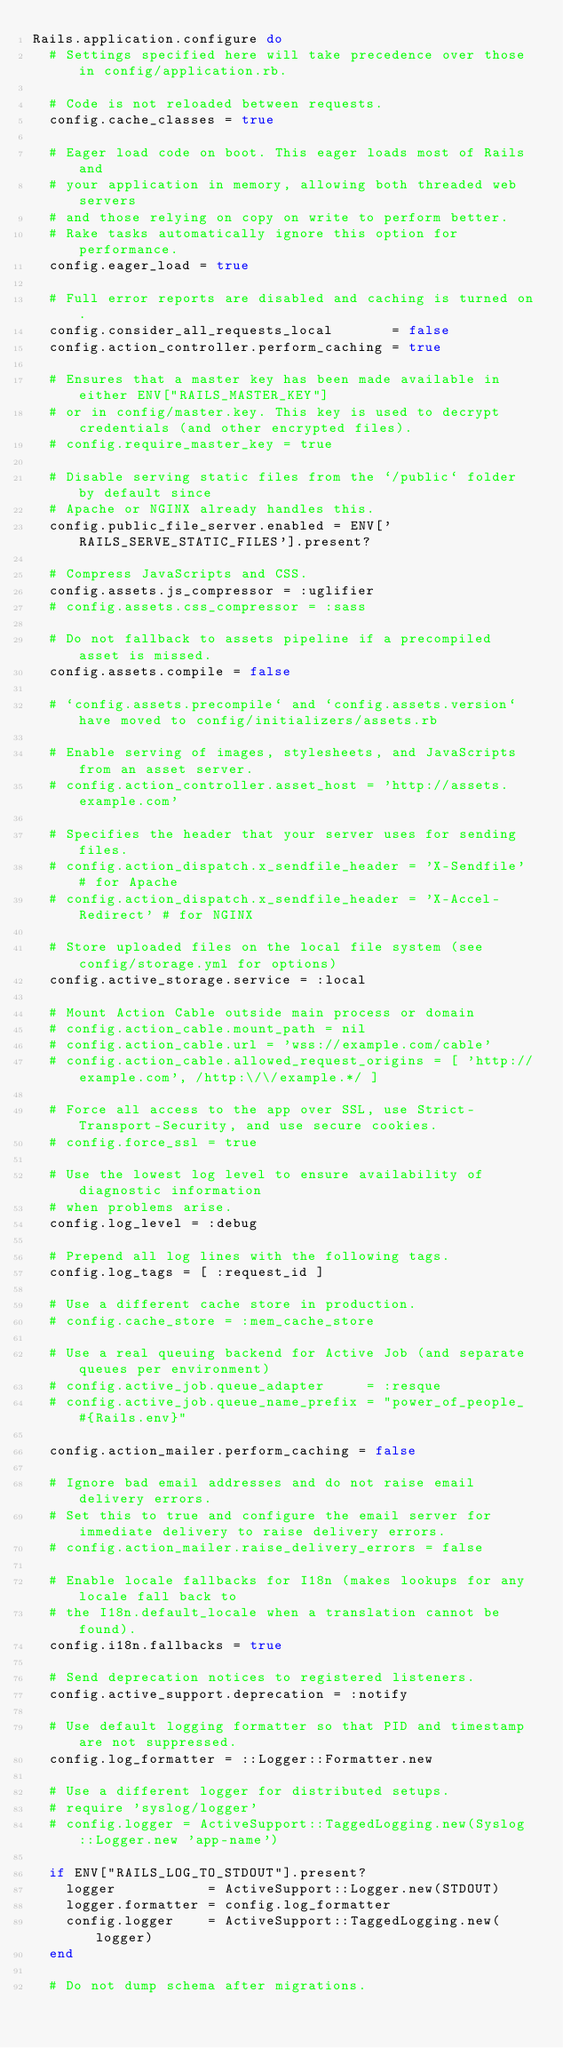<code> <loc_0><loc_0><loc_500><loc_500><_Ruby_>Rails.application.configure do
  # Settings specified here will take precedence over those in config/application.rb.

  # Code is not reloaded between requests.
  config.cache_classes = true

  # Eager load code on boot. This eager loads most of Rails and
  # your application in memory, allowing both threaded web servers
  # and those relying on copy on write to perform better.
  # Rake tasks automatically ignore this option for performance.
  config.eager_load = true

  # Full error reports are disabled and caching is turned on.
  config.consider_all_requests_local       = false
  config.action_controller.perform_caching = true

  # Ensures that a master key has been made available in either ENV["RAILS_MASTER_KEY"]
  # or in config/master.key. This key is used to decrypt credentials (and other encrypted files).
  # config.require_master_key = true

  # Disable serving static files from the `/public` folder by default since
  # Apache or NGINX already handles this.
  config.public_file_server.enabled = ENV['RAILS_SERVE_STATIC_FILES'].present?

  # Compress JavaScripts and CSS.
  config.assets.js_compressor = :uglifier
  # config.assets.css_compressor = :sass

  # Do not fallback to assets pipeline if a precompiled asset is missed.
  config.assets.compile = false

  # `config.assets.precompile` and `config.assets.version` have moved to config/initializers/assets.rb

  # Enable serving of images, stylesheets, and JavaScripts from an asset server.
  # config.action_controller.asset_host = 'http://assets.example.com'

  # Specifies the header that your server uses for sending files.
  # config.action_dispatch.x_sendfile_header = 'X-Sendfile' # for Apache
  # config.action_dispatch.x_sendfile_header = 'X-Accel-Redirect' # for NGINX

  # Store uploaded files on the local file system (see config/storage.yml for options)
  config.active_storage.service = :local

  # Mount Action Cable outside main process or domain
  # config.action_cable.mount_path = nil
  # config.action_cable.url = 'wss://example.com/cable'
  # config.action_cable.allowed_request_origins = [ 'http://example.com', /http:\/\/example.*/ ]

  # Force all access to the app over SSL, use Strict-Transport-Security, and use secure cookies.
  # config.force_ssl = true

  # Use the lowest log level to ensure availability of diagnostic information
  # when problems arise.
  config.log_level = :debug

  # Prepend all log lines with the following tags.
  config.log_tags = [ :request_id ]

  # Use a different cache store in production.
  # config.cache_store = :mem_cache_store

  # Use a real queuing backend for Active Job (and separate queues per environment)
  # config.active_job.queue_adapter     = :resque
  # config.active_job.queue_name_prefix = "power_of_people_#{Rails.env}"

  config.action_mailer.perform_caching = false

  # Ignore bad email addresses and do not raise email delivery errors.
  # Set this to true and configure the email server for immediate delivery to raise delivery errors.
  # config.action_mailer.raise_delivery_errors = false

  # Enable locale fallbacks for I18n (makes lookups for any locale fall back to
  # the I18n.default_locale when a translation cannot be found).
  config.i18n.fallbacks = true

  # Send deprecation notices to registered listeners.
  config.active_support.deprecation = :notify

  # Use default logging formatter so that PID and timestamp are not suppressed.
  config.log_formatter = ::Logger::Formatter.new

  # Use a different logger for distributed setups.
  # require 'syslog/logger'
  # config.logger = ActiveSupport::TaggedLogging.new(Syslog::Logger.new 'app-name')

  if ENV["RAILS_LOG_TO_STDOUT"].present?
    logger           = ActiveSupport::Logger.new(STDOUT)
    logger.formatter = config.log_formatter
    config.logger    = ActiveSupport::TaggedLogging.new(logger)
  end

  # Do not dump schema after migrations.</code> 